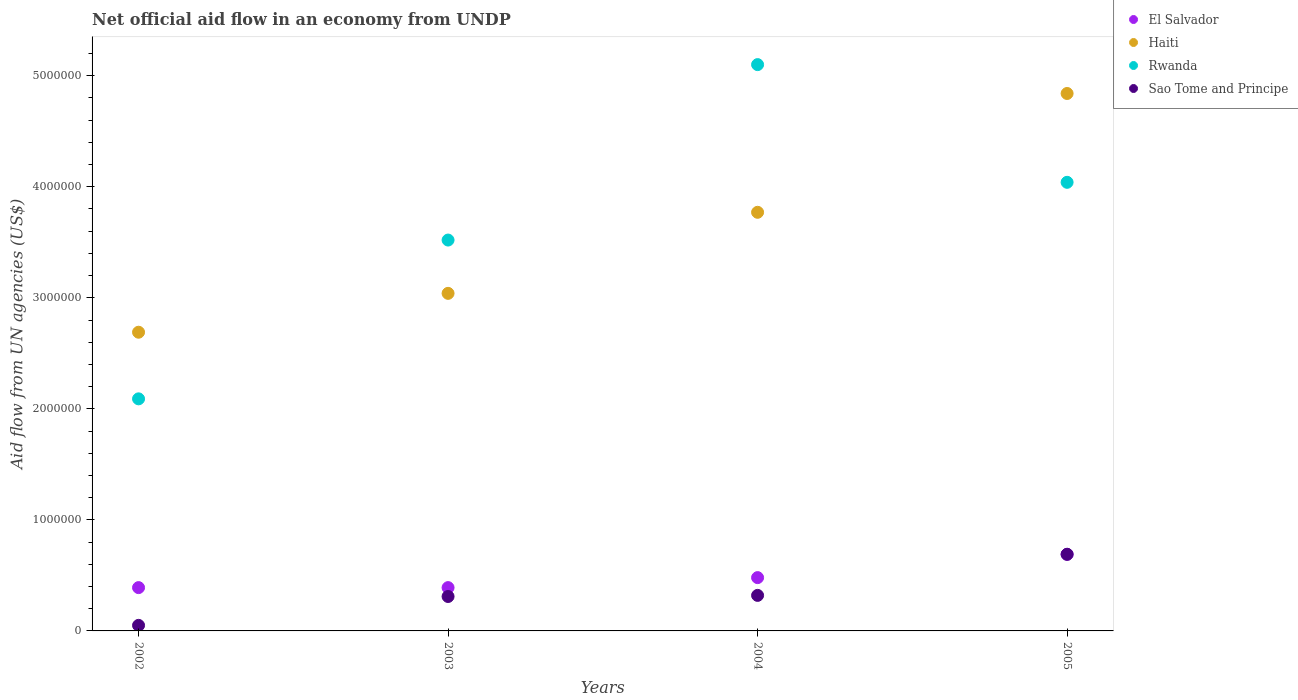How many different coloured dotlines are there?
Provide a short and direct response. 4. What is the net official aid flow in Haiti in 2005?
Ensure brevity in your answer.  4.84e+06. Across all years, what is the maximum net official aid flow in Sao Tome and Principe?
Keep it short and to the point. 6.90e+05. Across all years, what is the minimum net official aid flow in Rwanda?
Your answer should be very brief. 2.09e+06. In which year was the net official aid flow in Sao Tome and Principe maximum?
Give a very brief answer. 2005. What is the total net official aid flow in Rwanda in the graph?
Provide a succinct answer. 1.48e+07. What is the difference between the net official aid flow in El Salvador in 2002 and that in 2005?
Your answer should be very brief. -3.00e+05. What is the difference between the net official aid flow in Sao Tome and Principe in 2004 and the net official aid flow in El Salvador in 2003?
Your answer should be compact. -7.00e+04. What is the average net official aid flow in Sao Tome and Principe per year?
Keep it short and to the point. 3.42e+05. In the year 2004, what is the difference between the net official aid flow in El Salvador and net official aid flow in Rwanda?
Your response must be concise. -4.62e+06. What is the ratio of the net official aid flow in Sao Tome and Principe in 2002 to that in 2003?
Provide a succinct answer. 0.16. Is the difference between the net official aid flow in El Salvador in 2002 and 2005 greater than the difference between the net official aid flow in Rwanda in 2002 and 2005?
Provide a succinct answer. Yes. What is the difference between the highest and the second highest net official aid flow in Haiti?
Your response must be concise. 1.07e+06. What is the difference between the highest and the lowest net official aid flow in Sao Tome and Principe?
Your answer should be compact. 6.40e+05. Is it the case that in every year, the sum of the net official aid flow in Rwanda and net official aid flow in Sao Tome and Principe  is greater than the sum of net official aid flow in El Salvador and net official aid flow in Haiti?
Make the answer very short. No. Does the net official aid flow in Sao Tome and Principe monotonically increase over the years?
Offer a very short reply. Yes. How many years are there in the graph?
Give a very brief answer. 4. What is the difference between two consecutive major ticks on the Y-axis?
Make the answer very short. 1.00e+06. Does the graph contain grids?
Your response must be concise. No. How many legend labels are there?
Make the answer very short. 4. What is the title of the graph?
Your response must be concise. Net official aid flow in an economy from UNDP. What is the label or title of the X-axis?
Make the answer very short. Years. What is the label or title of the Y-axis?
Offer a terse response. Aid flow from UN agencies (US$). What is the Aid flow from UN agencies (US$) of El Salvador in 2002?
Give a very brief answer. 3.90e+05. What is the Aid flow from UN agencies (US$) of Haiti in 2002?
Ensure brevity in your answer.  2.69e+06. What is the Aid flow from UN agencies (US$) of Rwanda in 2002?
Give a very brief answer. 2.09e+06. What is the Aid flow from UN agencies (US$) in El Salvador in 2003?
Ensure brevity in your answer.  3.90e+05. What is the Aid flow from UN agencies (US$) in Haiti in 2003?
Your answer should be compact. 3.04e+06. What is the Aid flow from UN agencies (US$) in Rwanda in 2003?
Ensure brevity in your answer.  3.52e+06. What is the Aid flow from UN agencies (US$) of Sao Tome and Principe in 2003?
Your answer should be compact. 3.10e+05. What is the Aid flow from UN agencies (US$) of Haiti in 2004?
Make the answer very short. 3.77e+06. What is the Aid flow from UN agencies (US$) in Rwanda in 2004?
Make the answer very short. 5.10e+06. What is the Aid flow from UN agencies (US$) of Sao Tome and Principe in 2004?
Your answer should be compact. 3.20e+05. What is the Aid flow from UN agencies (US$) of El Salvador in 2005?
Your answer should be very brief. 6.90e+05. What is the Aid flow from UN agencies (US$) of Haiti in 2005?
Provide a succinct answer. 4.84e+06. What is the Aid flow from UN agencies (US$) of Rwanda in 2005?
Your answer should be very brief. 4.04e+06. What is the Aid flow from UN agencies (US$) in Sao Tome and Principe in 2005?
Provide a succinct answer. 6.90e+05. Across all years, what is the maximum Aid flow from UN agencies (US$) of El Salvador?
Your response must be concise. 6.90e+05. Across all years, what is the maximum Aid flow from UN agencies (US$) of Haiti?
Ensure brevity in your answer.  4.84e+06. Across all years, what is the maximum Aid flow from UN agencies (US$) of Rwanda?
Give a very brief answer. 5.10e+06. Across all years, what is the maximum Aid flow from UN agencies (US$) of Sao Tome and Principe?
Offer a very short reply. 6.90e+05. Across all years, what is the minimum Aid flow from UN agencies (US$) of Haiti?
Offer a terse response. 2.69e+06. Across all years, what is the minimum Aid flow from UN agencies (US$) in Rwanda?
Your answer should be very brief. 2.09e+06. What is the total Aid flow from UN agencies (US$) in El Salvador in the graph?
Your answer should be very brief. 1.95e+06. What is the total Aid flow from UN agencies (US$) in Haiti in the graph?
Offer a very short reply. 1.43e+07. What is the total Aid flow from UN agencies (US$) in Rwanda in the graph?
Offer a very short reply. 1.48e+07. What is the total Aid flow from UN agencies (US$) of Sao Tome and Principe in the graph?
Offer a terse response. 1.37e+06. What is the difference between the Aid flow from UN agencies (US$) in El Salvador in 2002 and that in 2003?
Offer a terse response. 0. What is the difference between the Aid flow from UN agencies (US$) of Haiti in 2002 and that in 2003?
Offer a terse response. -3.50e+05. What is the difference between the Aid flow from UN agencies (US$) in Rwanda in 2002 and that in 2003?
Provide a succinct answer. -1.43e+06. What is the difference between the Aid flow from UN agencies (US$) of Sao Tome and Principe in 2002 and that in 2003?
Provide a succinct answer. -2.60e+05. What is the difference between the Aid flow from UN agencies (US$) in El Salvador in 2002 and that in 2004?
Provide a short and direct response. -9.00e+04. What is the difference between the Aid flow from UN agencies (US$) of Haiti in 2002 and that in 2004?
Provide a succinct answer. -1.08e+06. What is the difference between the Aid flow from UN agencies (US$) of Rwanda in 2002 and that in 2004?
Your answer should be very brief. -3.01e+06. What is the difference between the Aid flow from UN agencies (US$) in El Salvador in 2002 and that in 2005?
Ensure brevity in your answer.  -3.00e+05. What is the difference between the Aid flow from UN agencies (US$) in Haiti in 2002 and that in 2005?
Offer a very short reply. -2.15e+06. What is the difference between the Aid flow from UN agencies (US$) in Rwanda in 2002 and that in 2005?
Ensure brevity in your answer.  -1.95e+06. What is the difference between the Aid flow from UN agencies (US$) in Sao Tome and Principe in 2002 and that in 2005?
Your answer should be compact. -6.40e+05. What is the difference between the Aid flow from UN agencies (US$) of El Salvador in 2003 and that in 2004?
Provide a short and direct response. -9.00e+04. What is the difference between the Aid flow from UN agencies (US$) of Haiti in 2003 and that in 2004?
Offer a very short reply. -7.30e+05. What is the difference between the Aid flow from UN agencies (US$) in Rwanda in 2003 and that in 2004?
Your response must be concise. -1.58e+06. What is the difference between the Aid flow from UN agencies (US$) in Sao Tome and Principe in 2003 and that in 2004?
Your answer should be very brief. -10000. What is the difference between the Aid flow from UN agencies (US$) of Haiti in 2003 and that in 2005?
Offer a very short reply. -1.80e+06. What is the difference between the Aid flow from UN agencies (US$) in Rwanda in 2003 and that in 2005?
Offer a very short reply. -5.20e+05. What is the difference between the Aid flow from UN agencies (US$) of Sao Tome and Principe in 2003 and that in 2005?
Offer a very short reply. -3.80e+05. What is the difference between the Aid flow from UN agencies (US$) of Haiti in 2004 and that in 2005?
Make the answer very short. -1.07e+06. What is the difference between the Aid flow from UN agencies (US$) of Rwanda in 2004 and that in 2005?
Your answer should be very brief. 1.06e+06. What is the difference between the Aid flow from UN agencies (US$) of Sao Tome and Principe in 2004 and that in 2005?
Your answer should be compact. -3.70e+05. What is the difference between the Aid flow from UN agencies (US$) in El Salvador in 2002 and the Aid flow from UN agencies (US$) in Haiti in 2003?
Offer a terse response. -2.65e+06. What is the difference between the Aid flow from UN agencies (US$) of El Salvador in 2002 and the Aid flow from UN agencies (US$) of Rwanda in 2003?
Provide a short and direct response. -3.13e+06. What is the difference between the Aid flow from UN agencies (US$) in El Salvador in 2002 and the Aid flow from UN agencies (US$) in Sao Tome and Principe in 2003?
Give a very brief answer. 8.00e+04. What is the difference between the Aid flow from UN agencies (US$) of Haiti in 2002 and the Aid flow from UN agencies (US$) of Rwanda in 2003?
Offer a very short reply. -8.30e+05. What is the difference between the Aid flow from UN agencies (US$) in Haiti in 2002 and the Aid flow from UN agencies (US$) in Sao Tome and Principe in 2003?
Your answer should be compact. 2.38e+06. What is the difference between the Aid flow from UN agencies (US$) of Rwanda in 2002 and the Aid flow from UN agencies (US$) of Sao Tome and Principe in 2003?
Keep it short and to the point. 1.78e+06. What is the difference between the Aid flow from UN agencies (US$) in El Salvador in 2002 and the Aid flow from UN agencies (US$) in Haiti in 2004?
Ensure brevity in your answer.  -3.38e+06. What is the difference between the Aid flow from UN agencies (US$) in El Salvador in 2002 and the Aid flow from UN agencies (US$) in Rwanda in 2004?
Your answer should be very brief. -4.71e+06. What is the difference between the Aid flow from UN agencies (US$) in Haiti in 2002 and the Aid flow from UN agencies (US$) in Rwanda in 2004?
Provide a short and direct response. -2.41e+06. What is the difference between the Aid flow from UN agencies (US$) in Haiti in 2002 and the Aid flow from UN agencies (US$) in Sao Tome and Principe in 2004?
Ensure brevity in your answer.  2.37e+06. What is the difference between the Aid flow from UN agencies (US$) in Rwanda in 2002 and the Aid flow from UN agencies (US$) in Sao Tome and Principe in 2004?
Provide a succinct answer. 1.77e+06. What is the difference between the Aid flow from UN agencies (US$) of El Salvador in 2002 and the Aid flow from UN agencies (US$) of Haiti in 2005?
Offer a terse response. -4.45e+06. What is the difference between the Aid flow from UN agencies (US$) in El Salvador in 2002 and the Aid flow from UN agencies (US$) in Rwanda in 2005?
Provide a short and direct response. -3.65e+06. What is the difference between the Aid flow from UN agencies (US$) in Haiti in 2002 and the Aid flow from UN agencies (US$) in Rwanda in 2005?
Your response must be concise. -1.35e+06. What is the difference between the Aid flow from UN agencies (US$) of Haiti in 2002 and the Aid flow from UN agencies (US$) of Sao Tome and Principe in 2005?
Your answer should be very brief. 2.00e+06. What is the difference between the Aid flow from UN agencies (US$) in Rwanda in 2002 and the Aid flow from UN agencies (US$) in Sao Tome and Principe in 2005?
Offer a very short reply. 1.40e+06. What is the difference between the Aid flow from UN agencies (US$) in El Salvador in 2003 and the Aid flow from UN agencies (US$) in Haiti in 2004?
Your response must be concise. -3.38e+06. What is the difference between the Aid flow from UN agencies (US$) in El Salvador in 2003 and the Aid flow from UN agencies (US$) in Rwanda in 2004?
Your response must be concise. -4.71e+06. What is the difference between the Aid flow from UN agencies (US$) of Haiti in 2003 and the Aid flow from UN agencies (US$) of Rwanda in 2004?
Your response must be concise. -2.06e+06. What is the difference between the Aid flow from UN agencies (US$) of Haiti in 2003 and the Aid flow from UN agencies (US$) of Sao Tome and Principe in 2004?
Keep it short and to the point. 2.72e+06. What is the difference between the Aid flow from UN agencies (US$) of Rwanda in 2003 and the Aid flow from UN agencies (US$) of Sao Tome and Principe in 2004?
Keep it short and to the point. 3.20e+06. What is the difference between the Aid flow from UN agencies (US$) of El Salvador in 2003 and the Aid flow from UN agencies (US$) of Haiti in 2005?
Keep it short and to the point. -4.45e+06. What is the difference between the Aid flow from UN agencies (US$) of El Salvador in 2003 and the Aid flow from UN agencies (US$) of Rwanda in 2005?
Keep it short and to the point. -3.65e+06. What is the difference between the Aid flow from UN agencies (US$) of Haiti in 2003 and the Aid flow from UN agencies (US$) of Rwanda in 2005?
Your response must be concise. -1.00e+06. What is the difference between the Aid flow from UN agencies (US$) in Haiti in 2003 and the Aid flow from UN agencies (US$) in Sao Tome and Principe in 2005?
Your response must be concise. 2.35e+06. What is the difference between the Aid flow from UN agencies (US$) of Rwanda in 2003 and the Aid flow from UN agencies (US$) of Sao Tome and Principe in 2005?
Your answer should be very brief. 2.83e+06. What is the difference between the Aid flow from UN agencies (US$) of El Salvador in 2004 and the Aid flow from UN agencies (US$) of Haiti in 2005?
Give a very brief answer. -4.36e+06. What is the difference between the Aid flow from UN agencies (US$) of El Salvador in 2004 and the Aid flow from UN agencies (US$) of Rwanda in 2005?
Provide a succinct answer. -3.56e+06. What is the difference between the Aid flow from UN agencies (US$) in El Salvador in 2004 and the Aid flow from UN agencies (US$) in Sao Tome and Principe in 2005?
Offer a very short reply. -2.10e+05. What is the difference between the Aid flow from UN agencies (US$) of Haiti in 2004 and the Aid flow from UN agencies (US$) of Rwanda in 2005?
Make the answer very short. -2.70e+05. What is the difference between the Aid flow from UN agencies (US$) in Haiti in 2004 and the Aid flow from UN agencies (US$) in Sao Tome and Principe in 2005?
Your response must be concise. 3.08e+06. What is the difference between the Aid flow from UN agencies (US$) of Rwanda in 2004 and the Aid flow from UN agencies (US$) of Sao Tome and Principe in 2005?
Give a very brief answer. 4.41e+06. What is the average Aid flow from UN agencies (US$) of El Salvador per year?
Keep it short and to the point. 4.88e+05. What is the average Aid flow from UN agencies (US$) of Haiti per year?
Give a very brief answer. 3.58e+06. What is the average Aid flow from UN agencies (US$) of Rwanda per year?
Your response must be concise. 3.69e+06. What is the average Aid flow from UN agencies (US$) in Sao Tome and Principe per year?
Give a very brief answer. 3.42e+05. In the year 2002, what is the difference between the Aid flow from UN agencies (US$) in El Salvador and Aid flow from UN agencies (US$) in Haiti?
Your answer should be very brief. -2.30e+06. In the year 2002, what is the difference between the Aid flow from UN agencies (US$) in El Salvador and Aid flow from UN agencies (US$) in Rwanda?
Ensure brevity in your answer.  -1.70e+06. In the year 2002, what is the difference between the Aid flow from UN agencies (US$) of El Salvador and Aid flow from UN agencies (US$) of Sao Tome and Principe?
Your answer should be very brief. 3.40e+05. In the year 2002, what is the difference between the Aid flow from UN agencies (US$) in Haiti and Aid flow from UN agencies (US$) in Sao Tome and Principe?
Provide a short and direct response. 2.64e+06. In the year 2002, what is the difference between the Aid flow from UN agencies (US$) in Rwanda and Aid flow from UN agencies (US$) in Sao Tome and Principe?
Offer a very short reply. 2.04e+06. In the year 2003, what is the difference between the Aid flow from UN agencies (US$) of El Salvador and Aid flow from UN agencies (US$) of Haiti?
Provide a succinct answer. -2.65e+06. In the year 2003, what is the difference between the Aid flow from UN agencies (US$) in El Salvador and Aid flow from UN agencies (US$) in Rwanda?
Provide a succinct answer. -3.13e+06. In the year 2003, what is the difference between the Aid flow from UN agencies (US$) in Haiti and Aid flow from UN agencies (US$) in Rwanda?
Provide a succinct answer. -4.80e+05. In the year 2003, what is the difference between the Aid flow from UN agencies (US$) in Haiti and Aid flow from UN agencies (US$) in Sao Tome and Principe?
Provide a short and direct response. 2.73e+06. In the year 2003, what is the difference between the Aid flow from UN agencies (US$) of Rwanda and Aid flow from UN agencies (US$) of Sao Tome and Principe?
Your answer should be compact. 3.21e+06. In the year 2004, what is the difference between the Aid flow from UN agencies (US$) of El Salvador and Aid flow from UN agencies (US$) of Haiti?
Your response must be concise. -3.29e+06. In the year 2004, what is the difference between the Aid flow from UN agencies (US$) in El Salvador and Aid flow from UN agencies (US$) in Rwanda?
Offer a very short reply. -4.62e+06. In the year 2004, what is the difference between the Aid flow from UN agencies (US$) in Haiti and Aid flow from UN agencies (US$) in Rwanda?
Your answer should be very brief. -1.33e+06. In the year 2004, what is the difference between the Aid flow from UN agencies (US$) in Haiti and Aid flow from UN agencies (US$) in Sao Tome and Principe?
Offer a very short reply. 3.45e+06. In the year 2004, what is the difference between the Aid flow from UN agencies (US$) in Rwanda and Aid flow from UN agencies (US$) in Sao Tome and Principe?
Offer a terse response. 4.78e+06. In the year 2005, what is the difference between the Aid flow from UN agencies (US$) in El Salvador and Aid flow from UN agencies (US$) in Haiti?
Offer a very short reply. -4.15e+06. In the year 2005, what is the difference between the Aid flow from UN agencies (US$) in El Salvador and Aid flow from UN agencies (US$) in Rwanda?
Provide a succinct answer. -3.35e+06. In the year 2005, what is the difference between the Aid flow from UN agencies (US$) in Haiti and Aid flow from UN agencies (US$) in Rwanda?
Your response must be concise. 8.00e+05. In the year 2005, what is the difference between the Aid flow from UN agencies (US$) in Haiti and Aid flow from UN agencies (US$) in Sao Tome and Principe?
Your answer should be compact. 4.15e+06. In the year 2005, what is the difference between the Aid flow from UN agencies (US$) in Rwanda and Aid flow from UN agencies (US$) in Sao Tome and Principe?
Provide a short and direct response. 3.35e+06. What is the ratio of the Aid flow from UN agencies (US$) in El Salvador in 2002 to that in 2003?
Provide a short and direct response. 1. What is the ratio of the Aid flow from UN agencies (US$) in Haiti in 2002 to that in 2003?
Give a very brief answer. 0.88. What is the ratio of the Aid flow from UN agencies (US$) of Rwanda in 2002 to that in 2003?
Offer a very short reply. 0.59. What is the ratio of the Aid flow from UN agencies (US$) in Sao Tome and Principe in 2002 to that in 2003?
Make the answer very short. 0.16. What is the ratio of the Aid flow from UN agencies (US$) in El Salvador in 2002 to that in 2004?
Offer a terse response. 0.81. What is the ratio of the Aid flow from UN agencies (US$) in Haiti in 2002 to that in 2004?
Ensure brevity in your answer.  0.71. What is the ratio of the Aid flow from UN agencies (US$) in Rwanda in 2002 to that in 2004?
Make the answer very short. 0.41. What is the ratio of the Aid flow from UN agencies (US$) in Sao Tome and Principe in 2002 to that in 2004?
Make the answer very short. 0.16. What is the ratio of the Aid flow from UN agencies (US$) of El Salvador in 2002 to that in 2005?
Your answer should be very brief. 0.57. What is the ratio of the Aid flow from UN agencies (US$) of Haiti in 2002 to that in 2005?
Make the answer very short. 0.56. What is the ratio of the Aid flow from UN agencies (US$) of Rwanda in 2002 to that in 2005?
Ensure brevity in your answer.  0.52. What is the ratio of the Aid flow from UN agencies (US$) in Sao Tome and Principe in 2002 to that in 2005?
Offer a terse response. 0.07. What is the ratio of the Aid flow from UN agencies (US$) of El Salvador in 2003 to that in 2004?
Your answer should be compact. 0.81. What is the ratio of the Aid flow from UN agencies (US$) in Haiti in 2003 to that in 2004?
Provide a short and direct response. 0.81. What is the ratio of the Aid flow from UN agencies (US$) of Rwanda in 2003 to that in 2004?
Your answer should be compact. 0.69. What is the ratio of the Aid flow from UN agencies (US$) of Sao Tome and Principe in 2003 to that in 2004?
Your answer should be very brief. 0.97. What is the ratio of the Aid flow from UN agencies (US$) in El Salvador in 2003 to that in 2005?
Your response must be concise. 0.57. What is the ratio of the Aid flow from UN agencies (US$) in Haiti in 2003 to that in 2005?
Keep it short and to the point. 0.63. What is the ratio of the Aid flow from UN agencies (US$) of Rwanda in 2003 to that in 2005?
Give a very brief answer. 0.87. What is the ratio of the Aid flow from UN agencies (US$) in Sao Tome and Principe in 2003 to that in 2005?
Provide a succinct answer. 0.45. What is the ratio of the Aid flow from UN agencies (US$) of El Salvador in 2004 to that in 2005?
Keep it short and to the point. 0.7. What is the ratio of the Aid flow from UN agencies (US$) of Haiti in 2004 to that in 2005?
Ensure brevity in your answer.  0.78. What is the ratio of the Aid flow from UN agencies (US$) in Rwanda in 2004 to that in 2005?
Make the answer very short. 1.26. What is the ratio of the Aid flow from UN agencies (US$) of Sao Tome and Principe in 2004 to that in 2005?
Make the answer very short. 0.46. What is the difference between the highest and the second highest Aid flow from UN agencies (US$) in El Salvador?
Offer a terse response. 2.10e+05. What is the difference between the highest and the second highest Aid flow from UN agencies (US$) in Haiti?
Provide a succinct answer. 1.07e+06. What is the difference between the highest and the second highest Aid flow from UN agencies (US$) in Rwanda?
Keep it short and to the point. 1.06e+06. What is the difference between the highest and the lowest Aid flow from UN agencies (US$) of Haiti?
Provide a short and direct response. 2.15e+06. What is the difference between the highest and the lowest Aid flow from UN agencies (US$) in Rwanda?
Provide a succinct answer. 3.01e+06. What is the difference between the highest and the lowest Aid flow from UN agencies (US$) of Sao Tome and Principe?
Give a very brief answer. 6.40e+05. 